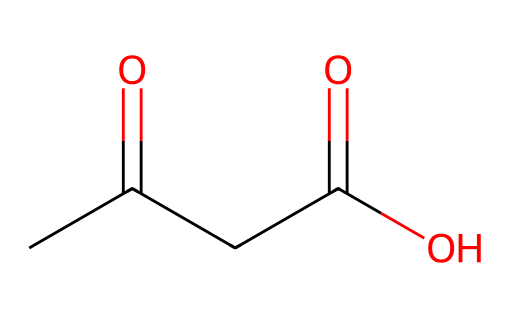What is the name of this chemical? The chemical's structure indicates the presence of a ketone functional group (C=O flanked by carbon chains), and it's specifically indicated by its SMILES representation, which corresponds to the compound acetoacetic acid.
Answer: acetoacetic acid How many carbon atoms are in this molecule? Looking at the SMILES representation, we can identify that there are four carbon atoms present in the structure (C). Counting each 'C' from left to right confirms this.
Answer: four What types of functional groups are present in this chemical? By analyzing the structure in the SMILES, we see a ketone (C=O) and a carboxylic acid (COOH) indicated by the -O and -OH groups. Therefore, both functional groups are present in this molecule.
Answer: ketone and carboxylic acid How many oxygen atoms does this molecule contain? From the SMILES representation, we can identify that there are three oxygen atoms present; one from the ketone and two from the carboxylic group (C=O and -OH).
Answer: three Why does this molecule have acidic properties? The presence of a carboxylic acid group (-COOH) in the structure is responsible for its acidic properties, as it can donate a proton (H+) in solution, creating acidity.
Answer: carboxylic acid group What type of chemical reaction might this molecule undergo? Given the presence of the carboxylic acid group, this molecule could undergo esterification reactions where it can react with alcohols to form esters. This is typical behavior for organic acids.
Answer: esterification 